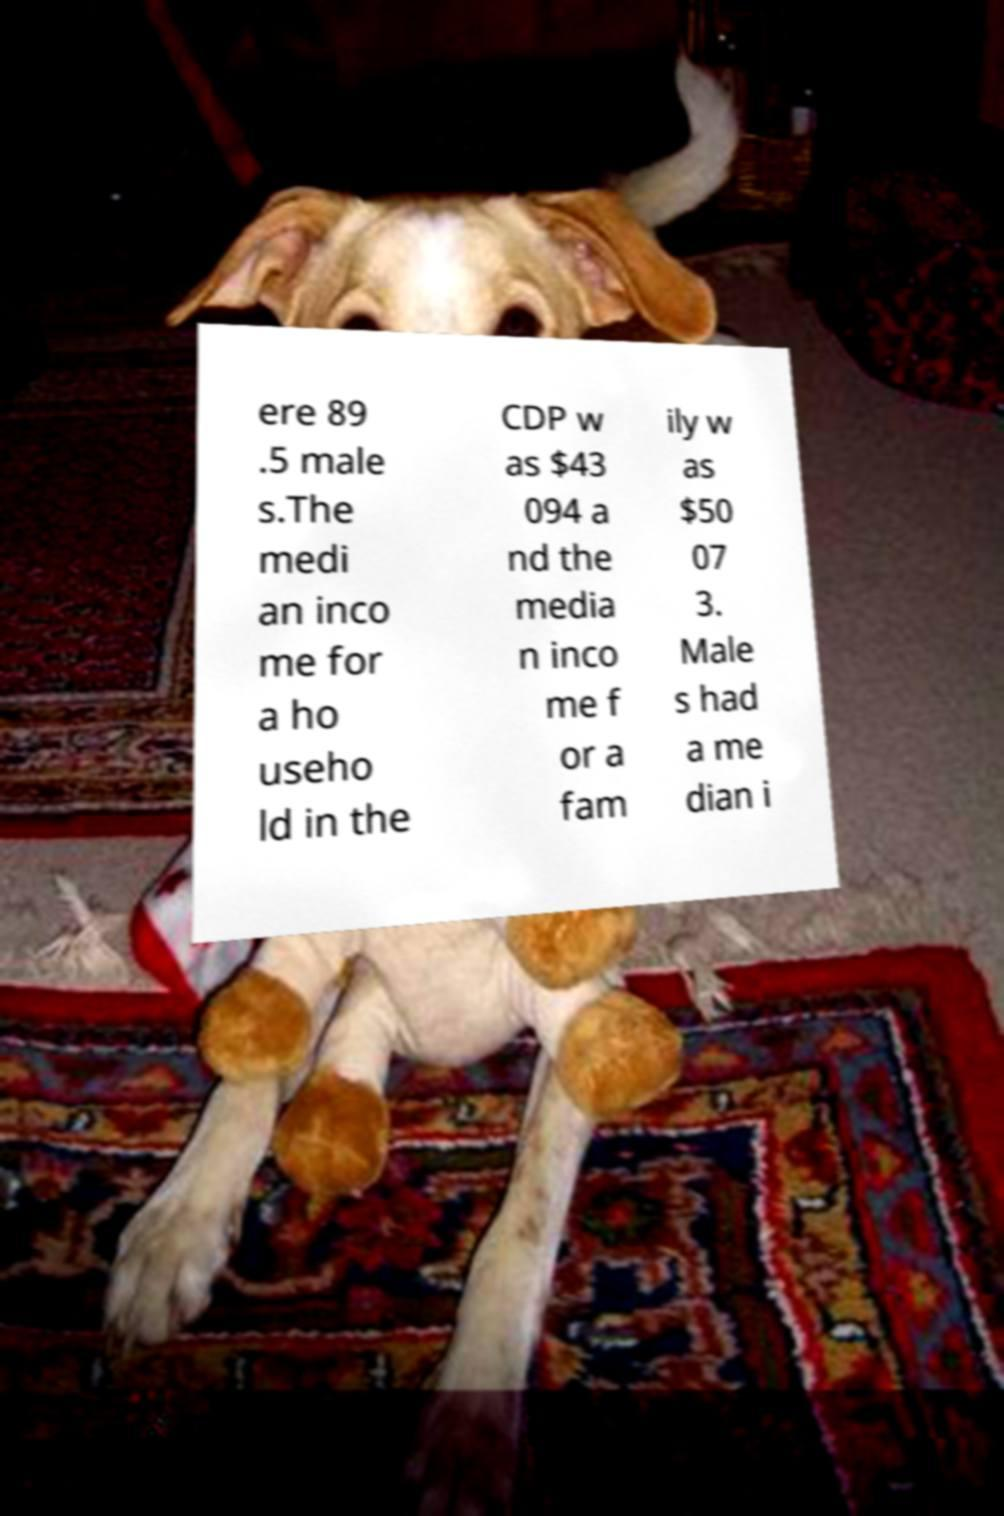Can you accurately transcribe the text from the provided image for me? ere 89 .5 male s.The medi an inco me for a ho useho ld in the CDP w as $43 094 a nd the media n inco me f or a fam ily w as $50 07 3. Male s had a me dian i 